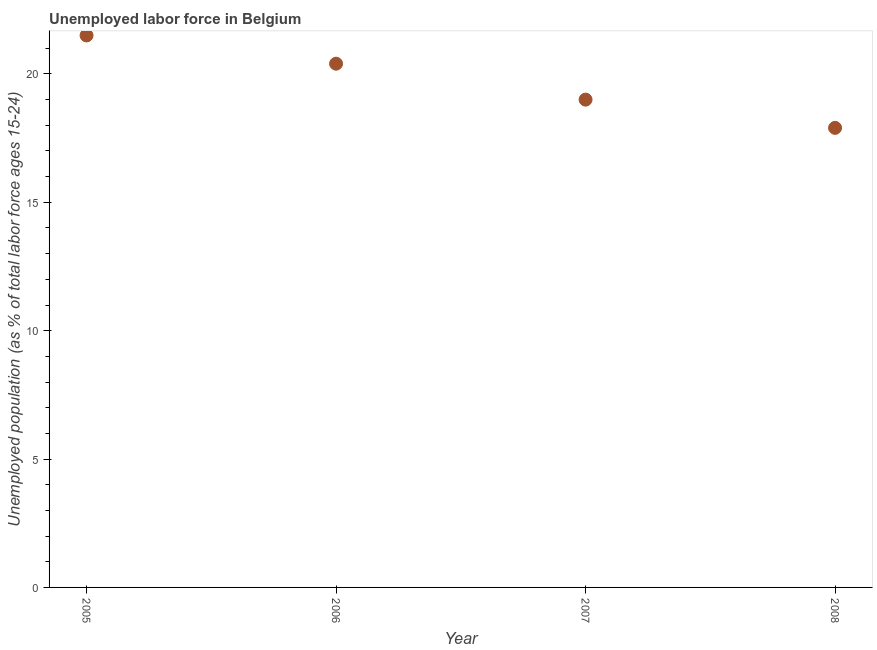What is the total unemployed youth population in 2006?
Offer a terse response. 20.4. Across all years, what is the minimum total unemployed youth population?
Make the answer very short. 17.9. In which year was the total unemployed youth population maximum?
Offer a very short reply. 2005. What is the sum of the total unemployed youth population?
Offer a terse response. 78.8. What is the difference between the total unemployed youth population in 2005 and 2006?
Provide a short and direct response. 1.1. What is the average total unemployed youth population per year?
Give a very brief answer. 19.7. What is the median total unemployed youth population?
Offer a terse response. 19.7. Do a majority of the years between 2006 and 2008 (inclusive) have total unemployed youth population greater than 11 %?
Keep it short and to the point. Yes. What is the ratio of the total unemployed youth population in 2007 to that in 2008?
Provide a short and direct response. 1.06. Is the total unemployed youth population in 2007 less than that in 2008?
Your response must be concise. No. Is the difference between the total unemployed youth population in 2007 and 2008 greater than the difference between any two years?
Your response must be concise. No. What is the difference between the highest and the second highest total unemployed youth population?
Provide a succinct answer. 1.1. What is the difference between the highest and the lowest total unemployed youth population?
Your answer should be very brief. 3.6. In how many years, is the total unemployed youth population greater than the average total unemployed youth population taken over all years?
Provide a succinct answer. 2. Does the total unemployed youth population monotonically increase over the years?
Ensure brevity in your answer.  No. How many dotlines are there?
Keep it short and to the point. 1. How many years are there in the graph?
Keep it short and to the point. 4. What is the difference between two consecutive major ticks on the Y-axis?
Your answer should be very brief. 5. Are the values on the major ticks of Y-axis written in scientific E-notation?
Make the answer very short. No. Does the graph contain any zero values?
Offer a very short reply. No. What is the title of the graph?
Your answer should be very brief. Unemployed labor force in Belgium. What is the label or title of the X-axis?
Ensure brevity in your answer.  Year. What is the label or title of the Y-axis?
Give a very brief answer. Unemployed population (as % of total labor force ages 15-24). What is the Unemployed population (as % of total labor force ages 15-24) in 2005?
Make the answer very short. 21.5. What is the Unemployed population (as % of total labor force ages 15-24) in 2006?
Offer a very short reply. 20.4. What is the Unemployed population (as % of total labor force ages 15-24) in 2007?
Your answer should be very brief. 19. What is the Unemployed population (as % of total labor force ages 15-24) in 2008?
Offer a very short reply. 17.9. What is the difference between the Unemployed population (as % of total labor force ages 15-24) in 2005 and 2006?
Give a very brief answer. 1.1. What is the difference between the Unemployed population (as % of total labor force ages 15-24) in 2005 and 2007?
Give a very brief answer. 2.5. What is the difference between the Unemployed population (as % of total labor force ages 15-24) in 2005 and 2008?
Keep it short and to the point. 3.6. What is the ratio of the Unemployed population (as % of total labor force ages 15-24) in 2005 to that in 2006?
Make the answer very short. 1.05. What is the ratio of the Unemployed population (as % of total labor force ages 15-24) in 2005 to that in 2007?
Your response must be concise. 1.13. What is the ratio of the Unemployed population (as % of total labor force ages 15-24) in 2005 to that in 2008?
Offer a very short reply. 1.2. What is the ratio of the Unemployed population (as % of total labor force ages 15-24) in 2006 to that in 2007?
Your answer should be compact. 1.07. What is the ratio of the Unemployed population (as % of total labor force ages 15-24) in 2006 to that in 2008?
Offer a terse response. 1.14. What is the ratio of the Unemployed population (as % of total labor force ages 15-24) in 2007 to that in 2008?
Provide a succinct answer. 1.06. 